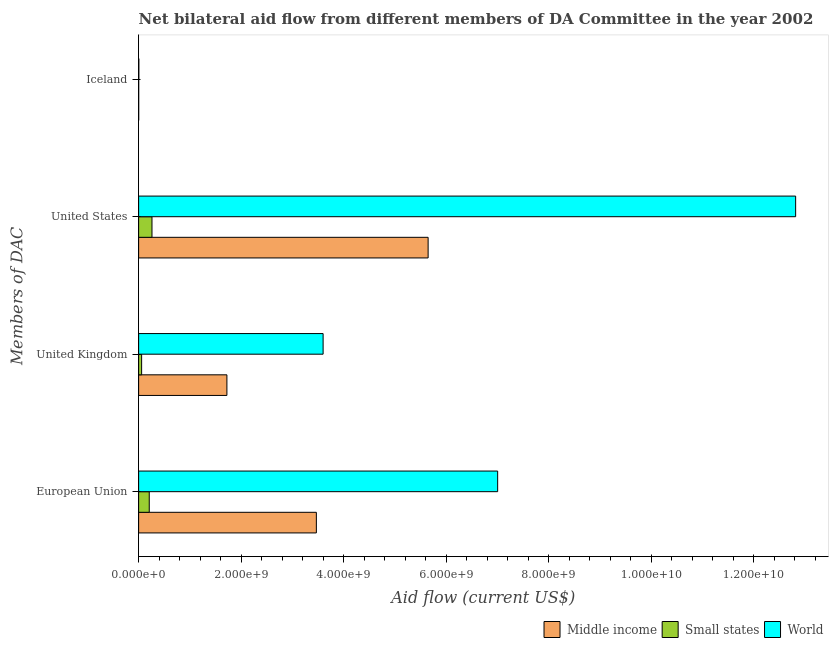How many groups of bars are there?
Provide a short and direct response. 4. How many bars are there on the 1st tick from the top?
Keep it short and to the point. 3. What is the amount of aid given by eu in Middle income?
Provide a succinct answer. 3.47e+09. Across all countries, what is the maximum amount of aid given by uk?
Give a very brief answer. 3.60e+09. Across all countries, what is the minimum amount of aid given by us?
Offer a terse response. 2.60e+08. In which country was the amount of aid given by uk maximum?
Provide a succinct answer. World. In which country was the amount of aid given by eu minimum?
Make the answer very short. Small states. What is the total amount of aid given by eu in the graph?
Ensure brevity in your answer.  1.07e+1. What is the difference between the amount of aid given by eu in World and that in Small states?
Give a very brief answer. 6.80e+09. What is the difference between the amount of aid given by uk in Small states and the amount of aid given by us in World?
Your response must be concise. -1.28e+1. What is the average amount of aid given by us per country?
Make the answer very short. 6.24e+09. What is the difference between the amount of aid given by iceland and amount of aid given by uk in World?
Ensure brevity in your answer.  -3.59e+09. In how many countries, is the amount of aid given by iceland greater than 5600000000 US$?
Provide a short and direct response. 0. What is the ratio of the amount of aid given by eu in World to that in Small states?
Provide a short and direct response. 33.8. What is the difference between the highest and the second highest amount of aid given by us?
Offer a terse response. 7.17e+09. What is the difference between the highest and the lowest amount of aid given by eu?
Your answer should be very brief. 6.80e+09. In how many countries, is the amount of aid given by iceland greater than the average amount of aid given by iceland taken over all countries?
Make the answer very short. 1. What does the 3rd bar from the top in United States represents?
Provide a succinct answer. Middle income. What does the 2nd bar from the bottom in Iceland represents?
Ensure brevity in your answer.  Small states. Is it the case that in every country, the sum of the amount of aid given by eu and amount of aid given by uk is greater than the amount of aid given by us?
Offer a very short reply. No. How many bars are there?
Make the answer very short. 12. Are all the bars in the graph horizontal?
Offer a terse response. Yes. How many countries are there in the graph?
Provide a succinct answer. 3. What is the difference between two consecutive major ticks on the X-axis?
Provide a short and direct response. 2.00e+09. Does the graph contain any zero values?
Your response must be concise. No. Where does the legend appear in the graph?
Your answer should be compact. Bottom right. What is the title of the graph?
Your answer should be compact. Net bilateral aid flow from different members of DA Committee in the year 2002. Does "Morocco" appear as one of the legend labels in the graph?
Offer a terse response. No. What is the label or title of the Y-axis?
Your answer should be very brief. Members of DAC. What is the Aid flow (current US$) of Middle income in European Union?
Your answer should be compact. 3.47e+09. What is the Aid flow (current US$) in Small states in European Union?
Your response must be concise. 2.07e+08. What is the Aid flow (current US$) in World in European Union?
Make the answer very short. 7.00e+09. What is the Aid flow (current US$) of Middle income in United Kingdom?
Your answer should be compact. 1.72e+09. What is the Aid flow (current US$) of Small states in United Kingdom?
Offer a very short reply. 5.85e+07. What is the Aid flow (current US$) in World in United Kingdom?
Provide a succinct answer. 3.60e+09. What is the Aid flow (current US$) of Middle income in United States?
Give a very brief answer. 5.65e+09. What is the Aid flow (current US$) in Small states in United States?
Your answer should be compact. 2.60e+08. What is the Aid flow (current US$) of World in United States?
Ensure brevity in your answer.  1.28e+1. What is the Aid flow (current US$) in Middle income in Iceland?
Ensure brevity in your answer.  1.18e+06. What is the Aid flow (current US$) in Small states in Iceland?
Provide a short and direct response. 1.18e+06. What is the Aid flow (current US$) of World in Iceland?
Make the answer very short. 4.30e+06. Across all Members of DAC, what is the maximum Aid flow (current US$) of Middle income?
Ensure brevity in your answer.  5.65e+09. Across all Members of DAC, what is the maximum Aid flow (current US$) in Small states?
Give a very brief answer. 2.60e+08. Across all Members of DAC, what is the maximum Aid flow (current US$) of World?
Make the answer very short. 1.28e+1. Across all Members of DAC, what is the minimum Aid flow (current US$) of Middle income?
Offer a very short reply. 1.18e+06. Across all Members of DAC, what is the minimum Aid flow (current US$) in Small states?
Offer a very short reply. 1.18e+06. Across all Members of DAC, what is the minimum Aid flow (current US$) in World?
Give a very brief answer. 4.30e+06. What is the total Aid flow (current US$) of Middle income in the graph?
Your answer should be compact. 1.08e+1. What is the total Aid flow (current US$) in Small states in the graph?
Ensure brevity in your answer.  5.27e+08. What is the total Aid flow (current US$) in World in the graph?
Give a very brief answer. 2.34e+1. What is the difference between the Aid flow (current US$) in Middle income in European Union and that in United Kingdom?
Provide a short and direct response. 1.74e+09. What is the difference between the Aid flow (current US$) in Small states in European Union and that in United Kingdom?
Your answer should be compact. 1.49e+08. What is the difference between the Aid flow (current US$) in World in European Union and that in United Kingdom?
Your answer should be very brief. 3.40e+09. What is the difference between the Aid flow (current US$) in Middle income in European Union and that in United States?
Your answer should be compact. -2.18e+09. What is the difference between the Aid flow (current US$) of Small states in European Union and that in United States?
Provide a succinct answer. -5.33e+07. What is the difference between the Aid flow (current US$) of World in European Union and that in United States?
Provide a short and direct response. -5.81e+09. What is the difference between the Aid flow (current US$) of Middle income in European Union and that in Iceland?
Provide a succinct answer. 3.47e+09. What is the difference between the Aid flow (current US$) in Small states in European Union and that in Iceland?
Offer a terse response. 2.06e+08. What is the difference between the Aid flow (current US$) of World in European Union and that in Iceland?
Offer a very short reply. 7.00e+09. What is the difference between the Aid flow (current US$) of Middle income in United Kingdom and that in United States?
Offer a very short reply. -3.92e+09. What is the difference between the Aid flow (current US$) of Small states in United Kingdom and that in United States?
Your answer should be very brief. -2.02e+08. What is the difference between the Aid flow (current US$) of World in United Kingdom and that in United States?
Ensure brevity in your answer.  -9.22e+09. What is the difference between the Aid flow (current US$) in Middle income in United Kingdom and that in Iceland?
Make the answer very short. 1.72e+09. What is the difference between the Aid flow (current US$) in Small states in United Kingdom and that in Iceland?
Keep it short and to the point. 5.74e+07. What is the difference between the Aid flow (current US$) in World in United Kingdom and that in Iceland?
Your response must be concise. 3.59e+09. What is the difference between the Aid flow (current US$) in Middle income in United States and that in Iceland?
Provide a short and direct response. 5.65e+09. What is the difference between the Aid flow (current US$) in Small states in United States and that in Iceland?
Your answer should be compact. 2.59e+08. What is the difference between the Aid flow (current US$) of World in United States and that in Iceland?
Make the answer very short. 1.28e+1. What is the difference between the Aid flow (current US$) of Middle income in European Union and the Aid flow (current US$) of Small states in United Kingdom?
Your answer should be compact. 3.41e+09. What is the difference between the Aid flow (current US$) in Middle income in European Union and the Aid flow (current US$) in World in United Kingdom?
Provide a succinct answer. -1.32e+08. What is the difference between the Aid flow (current US$) in Small states in European Union and the Aid flow (current US$) in World in United Kingdom?
Your answer should be very brief. -3.39e+09. What is the difference between the Aid flow (current US$) in Middle income in European Union and the Aid flow (current US$) in Small states in United States?
Your answer should be compact. 3.21e+09. What is the difference between the Aid flow (current US$) of Middle income in European Union and the Aid flow (current US$) of World in United States?
Your response must be concise. -9.35e+09. What is the difference between the Aid flow (current US$) in Small states in European Union and the Aid flow (current US$) in World in United States?
Your answer should be very brief. -1.26e+1. What is the difference between the Aid flow (current US$) of Middle income in European Union and the Aid flow (current US$) of Small states in Iceland?
Offer a terse response. 3.47e+09. What is the difference between the Aid flow (current US$) of Middle income in European Union and the Aid flow (current US$) of World in Iceland?
Offer a very short reply. 3.46e+09. What is the difference between the Aid flow (current US$) in Small states in European Union and the Aid flow (current US$) in World in Iceland?
Your answer should be very brief. 2.03e+08. What is the difference between the Aid flow (current US$) of Middle income in United Kingdom and the Aid flow (current US$) of Small states in United States?
Offer a terse response. 1.46e+09. What is the difference between the Aid flow (current US$) of Middle income in United Kingdom and the Aid flow (current US$) of World in United States?
Offer a very short reply. -1.11e+1. What is the difference between the Aid flow (current US$) in Small states in United Kingdom and the Aid flow (current US$) in World in United States?
Provide a succinct answer. -1.28e+1. What is the difference between the Aid flow (current US$) in Middle income in United Kingdom and the Aid flow (current US$) in Small states in Iceland?
Your answer should be compact. 1.72e+09. What is the difference between the Aid flow (current US$) in Middle income in United Kingdom and the Aid flow (current US$) in World in Iceland?
Make the answer very short. 1.72e+09. What is the difference between the Aid flow (current US$) of Small states in United Kingdom and the Aid flow (current US$) of World in Iceland?
Give a very brief answer. 5.42e+07. What is the difference between the Aid flow (current US$) of Middle income in United States and the Aid flow (current US$) of Small states in Iceland?
Provide a short and direct response. 5.65e+09. What is the difference between the Aid flow (current US$) in Middle income in United States and the Aid flow (current US$) in World in Iceland?
Provide a short and direct response. 5.64e+09. What is the difference between the Aid flow (current US$) of Small states in United States and the Aid flow (current US$) of World in Iceland?
Make the answer very short. 2.56e+08. What is the average Aid flow (current US$) of Middle income per Members of DAC?
Your answer should be compact. 2.71e+09. What is the average Aid flow (current US$) of Small states per Members of DAC?
Make the answer very short. 1.32e+08. What is the average Aid flow (current US$) of World per Members of DAC?
Provide a short and direct response. 5.85e+09. What is the difference between the Aid flow (current US$) in Middle income and Aid flow (current US$) in Small states in European Union?
Provide a short and direct response. 3.26e+09. What is the difference between the Aid flow (current US$) in Middle income and Aid flow (current US$) in World in European Union?
Provide a short and direct response. -3.54e+09. What is the difference between the Aid flow (current US$) of Small states and Aid flow (current US$) of World in European Union?
Your answer should be compact. -6.80e+09. What is the difference between the Aid flow (current US$) of Middle income and Aid flow (current US$) of Small states in United Kingdom?
Give a very brief answer. 1.66e+09. What is the difference between the Aid flow (current US$) of Middle income and Aid flow (current US$) of World in United Kingdom?
Provide a short and direct response. -1.88e+09. What is the difference between the Aid flow (current US$) in Small states and Aid flow (current US$) in World in United Kingdom?
Your answer should be very brief. -3.54e+09. What is the difference between the Aid flow (current US$) of Middle income and Aid flow (current US$) of Small states in United States?
Offer a terse response. 5.39e+09. What is the difference between the Aid flow (current US$) in Middle income and Aid flow (current US$) in World in United States?
Your response must be concise. -7.17e+09. What is the difference between the Aid flow (current US$) in Small states and Aid flow (current US$) in World in United States?
Keep it short and to the point. -1.26e+1. What is the difference between the Aid flow (current US$) of Middle income and Aid flow (current US$) of World in Iceland?
Your response must be concise. -3.12e+06. What is the difference between the Aid flow (current US$) of Small states and Aid flow (current US$) of World in Iceland?
Your answer should be compact. -3.12e+06. What is the ratio of the Aid flow (current US$) in Middle income in European Union to that in United Kingdom?
Offer a terse response. 2.01. What is the ratio of the Aid flow (current US$) of Small states in European Union to that in United Kingdom?
Your answer should be very brief. 3.54. What is the ratio of the Aid flow (current US$) in World in European Union to that in United Kingdom?
Provide a short and direct response. 1.95. What is the ratio of the Aid flow (current US$) in Middle income in European Union to that in United States?
Your answer should be very brief. 0.61. What is the ratio of the Aid flow (current US$) in Small states in European Union to that in United States?
Your answer should be compact. 0.8. What is the ratio of the Aid flow (current US$) of World in European Union to that in United States?
Make the answer very short. 0.55. What is the ratio of the Aid flow (current US$) in Middle income in European Union to that in Iceland?
Give a very brief answer. 2937.7. What is the ratio of the Aid flow (current US$) in Small states in European Union to that in Iceland?
Offer a very short reply. 175.55. What is the ratio of the Aid flow (current US$) of World in European Union to that in Iceland?
Your response must be concise. 1628.53. What is the ratio of the Aid flow (current US$) of Middle income in United Kingdom to that in United States?
Ensure brevity in your answer.  0.3. What is the ratio of the Aid flow (current US$) of Small states in United Kingdom to that in United States?
Your response must be concise. 0.22. What is the ratio of the Aid flow (current US$) of World in United Kingdom to that in United States?
Offer a very short reply. 0.28. What is the ratio of the Aid flow (current US$) of Middle income in United Kingdom to that in Iceland?
Offer a very short reply. 1459.14. What is the ratio of the Aid flow (current US$) of Small states in United Kingdom to that in Iceland?
Give a very brief answer. 49.6. What is the ratio of the Aid flow (current US$) in World in United Kingdom to that in Iceland?
Provide a succinct answer. 836.75. What is the ratio of the Aid flow (current US$) of Middle income in United States to that in Iceland?
Ensure brevity in your answer.  4785.18. What is the ratio of the Aid flow (current US$) of Small states in United States to that in Iceland?
Ensure brevity in your answer.  220.73. What is the ratio of the Aid flow (current US$) in World in United States to that in Iceland?
Offer a very short reply. 2980.12. What is the difference between the highest and the second highest Aid flow (current US$) of Middle income?
Your answer should be compact. 2.18e+09. What is the difference between the highest and the second highest Aid flow (current US$) of Small states?
Make the answer very short. 5.33e+07. What is the difference between the highest and the second highest Aid flow (current US$) of World?
Offer a very short reply. 5.81e+09. What is the difference between the highest and the lowest Aid flow (current US$) of Middle income?
Offer a terse response. 5.65e+09. What is the difference between the highest and the lowest Aid flow (current US$) of Small states?
Offer a very short reply. 2.59e+08. What is the difference between the highest and the lowest Aid flow (current US$) of World?
Provide a short and direct response. 1.28e+1. 